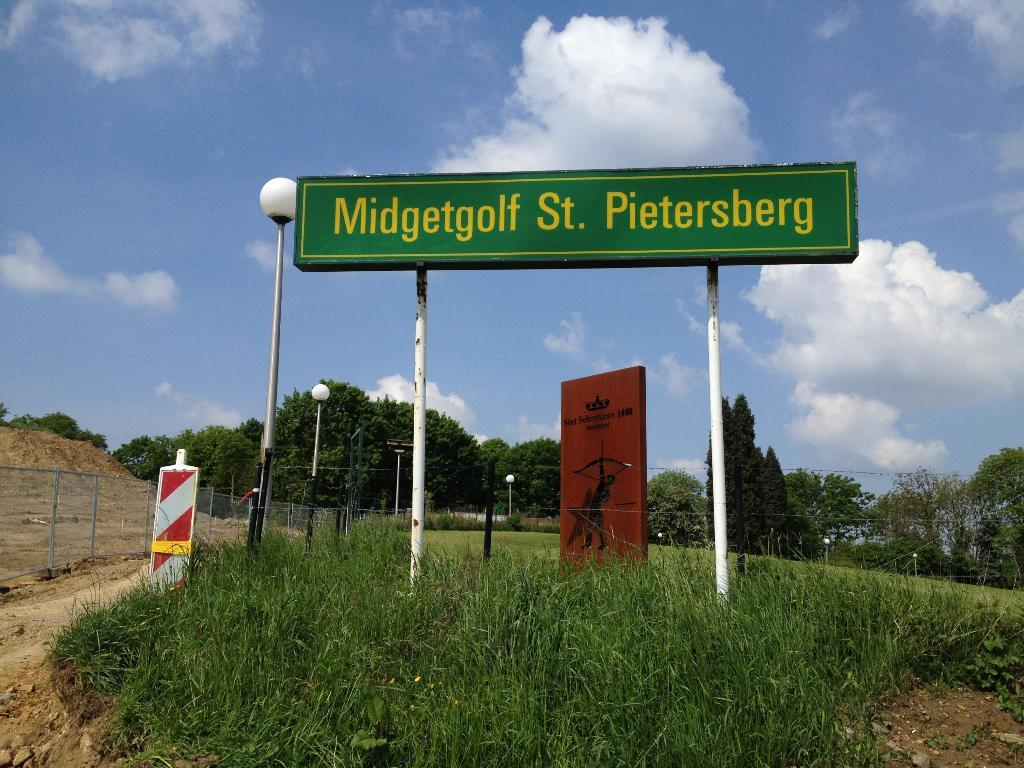<image>
Offer a succinct explanation of the picture presented. a sign that has the town name st. pietersberg 